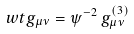Convert formula to latex. <formula><loc_0><loc_0><loc_500><loc_500>\ w t g _ { \mu \nu } = \psi ^ { - 2 } \, { g } ^ { ( 3 ) } _ { \mu \nu }</formula> 